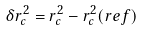<formula> <loc_0><loc_0><loc_500><loc_500>\delta r _ { c } ^ { 2 } = r _ { c } ^ { 2 } - r _ { c } ^ { 2 } ( r e f )</formula> 